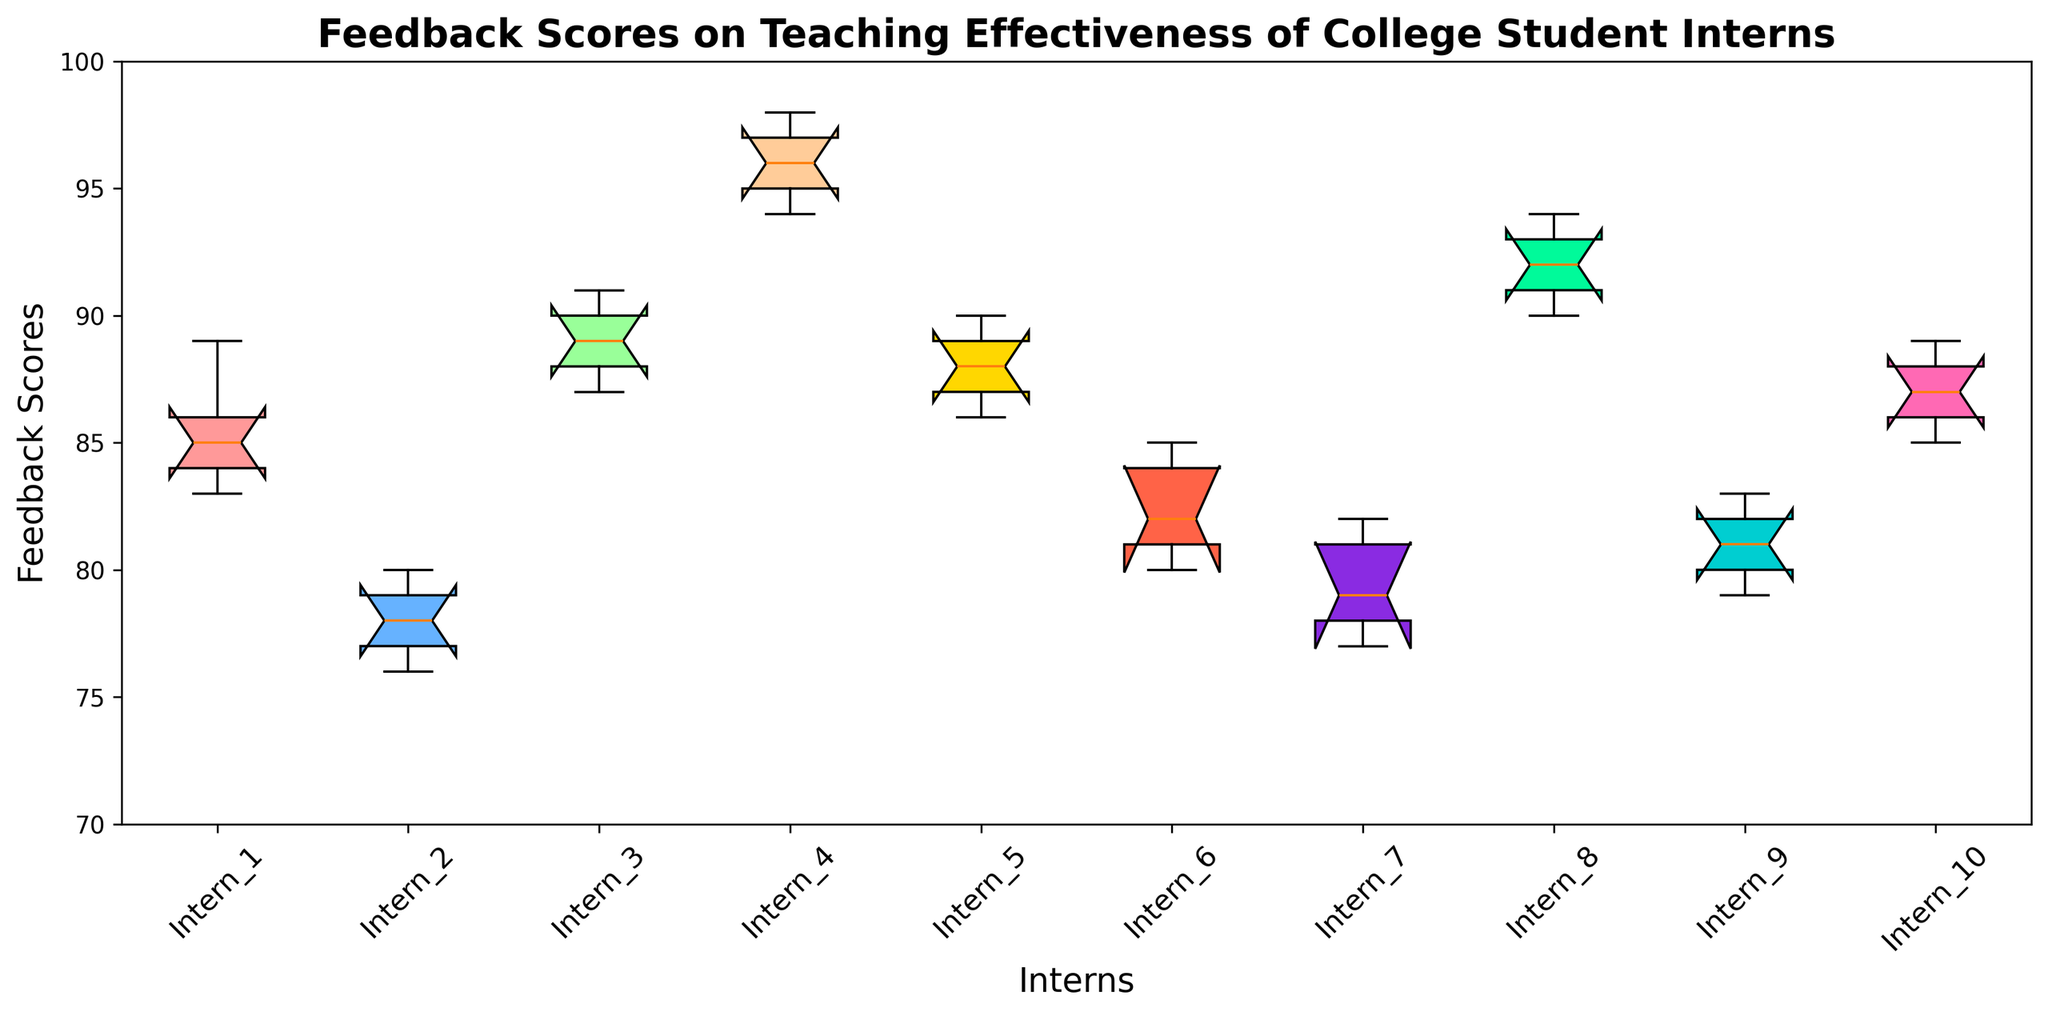Which intern has the highest median feedback score? Check each boxplot and identify the intern whose median (horizontal line within the box) is the highest. Intern_4's median appears to be the highest.
Answer: Intern_4 What is the range between the highest and lowest feedback scores for Intern_2? Look at the top and bottom "whiskers" of Intern_2's boxplot to identify the highest and lowest scores. The highest score is 80 and the lowest is 76, so the range is 80 - 76 = 4.
Answer: 4 Which intern has the lowest minimum feedback score? Observe the bottom whisker across all boxplots and identify the lowest point. Intern_9 has the lowest minimum score.
Answer: Intern_9 How does Intern_10's interquartile range (IQR) compare with Intern_3's? Compare the height of the boxes (IQR) for Intern_10 and Intern_3. Intern_10's box is slightly narrower (indicating a smaller IQR) than Intern_3's.
Answer: Intern_10 has a smaller IQR What is the median feedback score for Intern_5? Identify the horizontal line inside the box of Intern_5's boxplot. The median appears to be around 87.
Answer: 87 Which intern has the highest variability in feedback scores? Find the intern with the tallest box and whiskers, indicating the largest range and IQR. Intern_4 appears to have the highest range and variability.
Answer: Intern_4 Are any of the feedback scores for Intern_1 higher than the maximum score for Intern_6? Compare the top of the whiskers for both interns. The highest score for Intern_1 is around 89, and for Intern_6, it is around 85. Since 89 > 85, the answer is yes.
Answer: Yes What is the difference between the medians of Intern_8 and Intern_7? Identify the median lines for both interns. Intern_8's median is around 92, and Intern_7's is around 79. The difference is 92 - 79 = 13.
Answer: 13 Which intern has the most consistent feedback scores (smallest IQR)? Look for the intern with the smallest IQR (shortest box). Intern_10 seems to have the narrowest box, indicating the smallest IQR.
Answer: Intern_10 